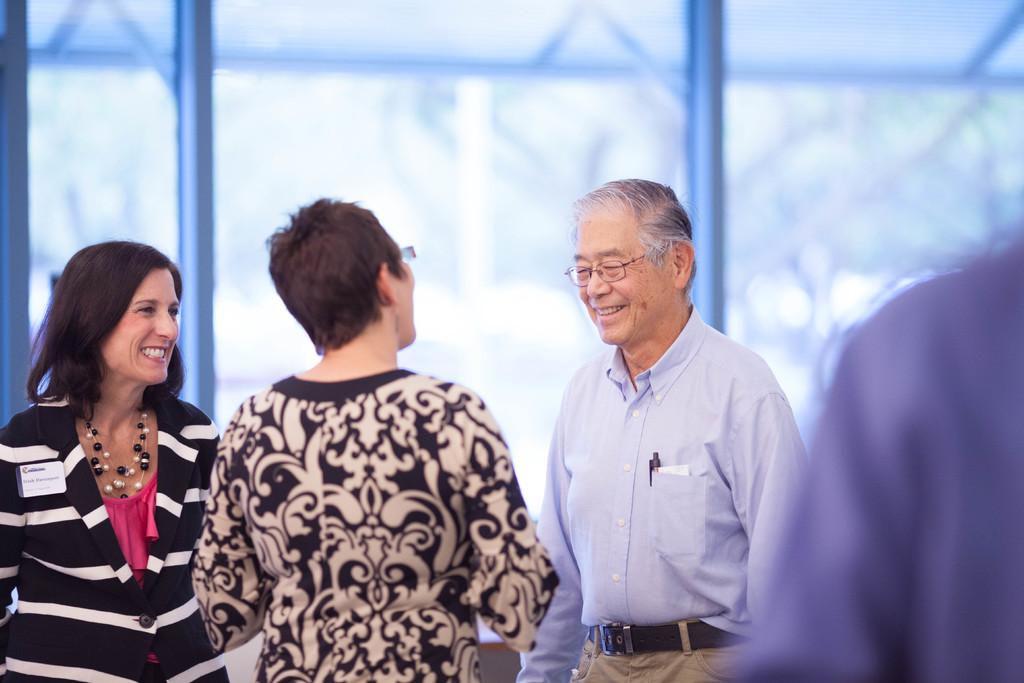What is the main subject of the image? The main subject of the image is people standing in the center. Can you describe the background of the image? The background of the image features rods. What type of hair can be seen on the people in the image? There is no information about hair in the image, as the facts provided only mention people standing in the center and rods in the background. 